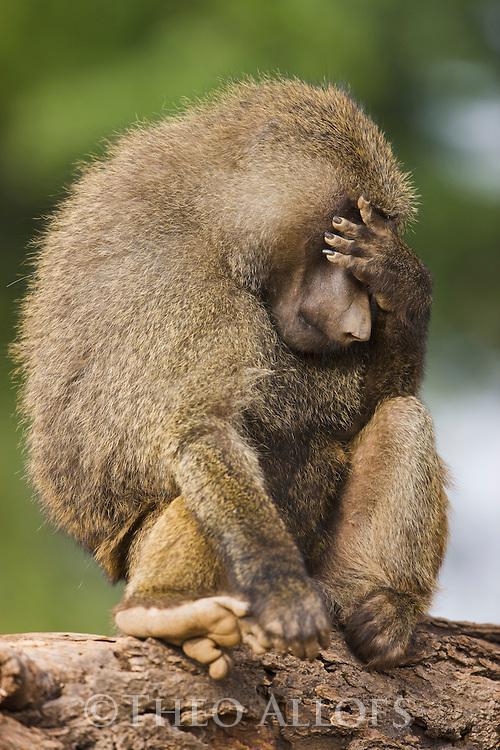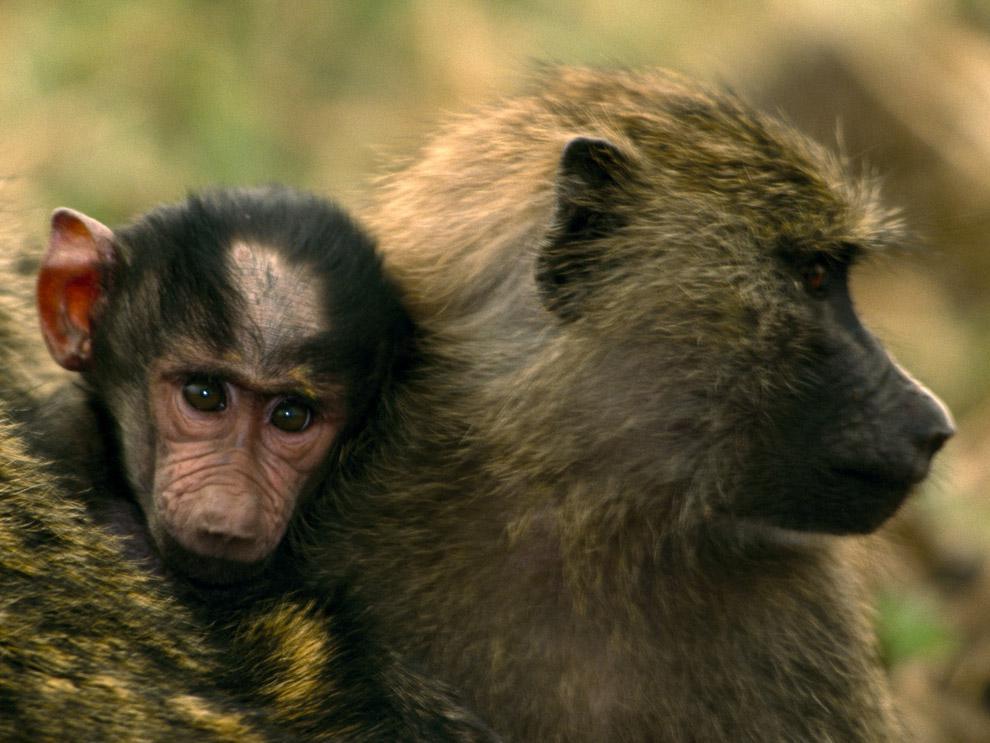The first image is the image on the left, the second image is the image on the right. Given the left and right images, does the statement "In one of the images, the animal's mouth is open as it bears its teeth" hold true? Answer yes or no. No. 